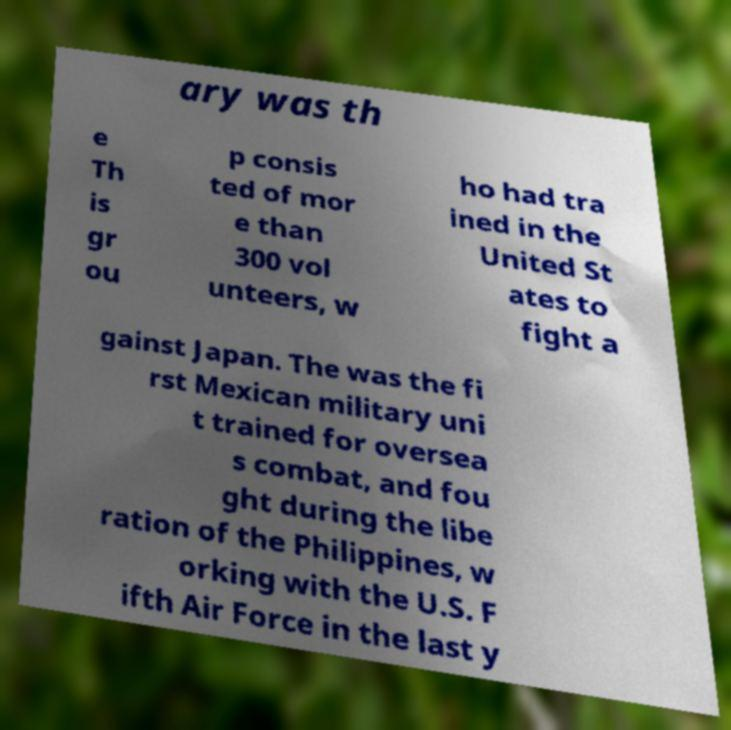For documentation purposes, I need the text within this image transcribed. Could you provide that? ary was th e Th is gr ou p consis ted of mor e than 300 vol unteers, w ho had tra ined in the United St ates to fight a gainst Japan. The was the fi rst Mexican military uni t trained for oversea s combat, and fou ght during the libe ration of the Philippines, w orking with the U.S. F ifth Air Force in the last y 